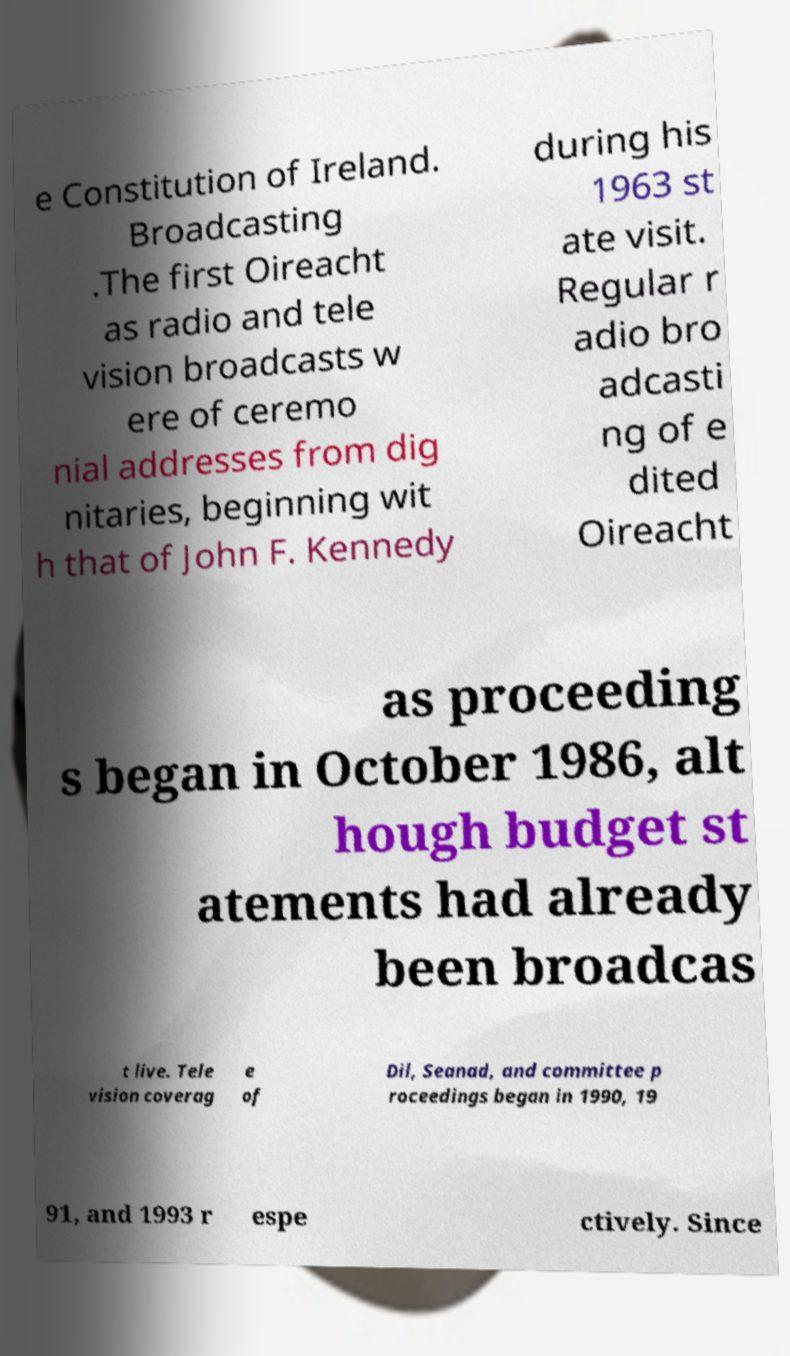Can you read and provide the text displayed in the image?This photo seems to have some interesting text. Can you extract and type it out for me? e Constitution of Ireland. Broadcasting .The first Oireacht as radio and tele vision broadcasts w ere of ceremo nial addresses from dig nitaries, beginning wit h that of John F. Kennedy during his 1963 st ate visit. Regular r adio bro adcasti ng of e dited Oireacht as proceeding s began in October 1986, alt hough budget st atements had already been broadcas t live. Tele vision coverag e of Dil, Seanad, and committee p roceedings began in 1990, 19 91, and 1993 r espe ctively. Since 